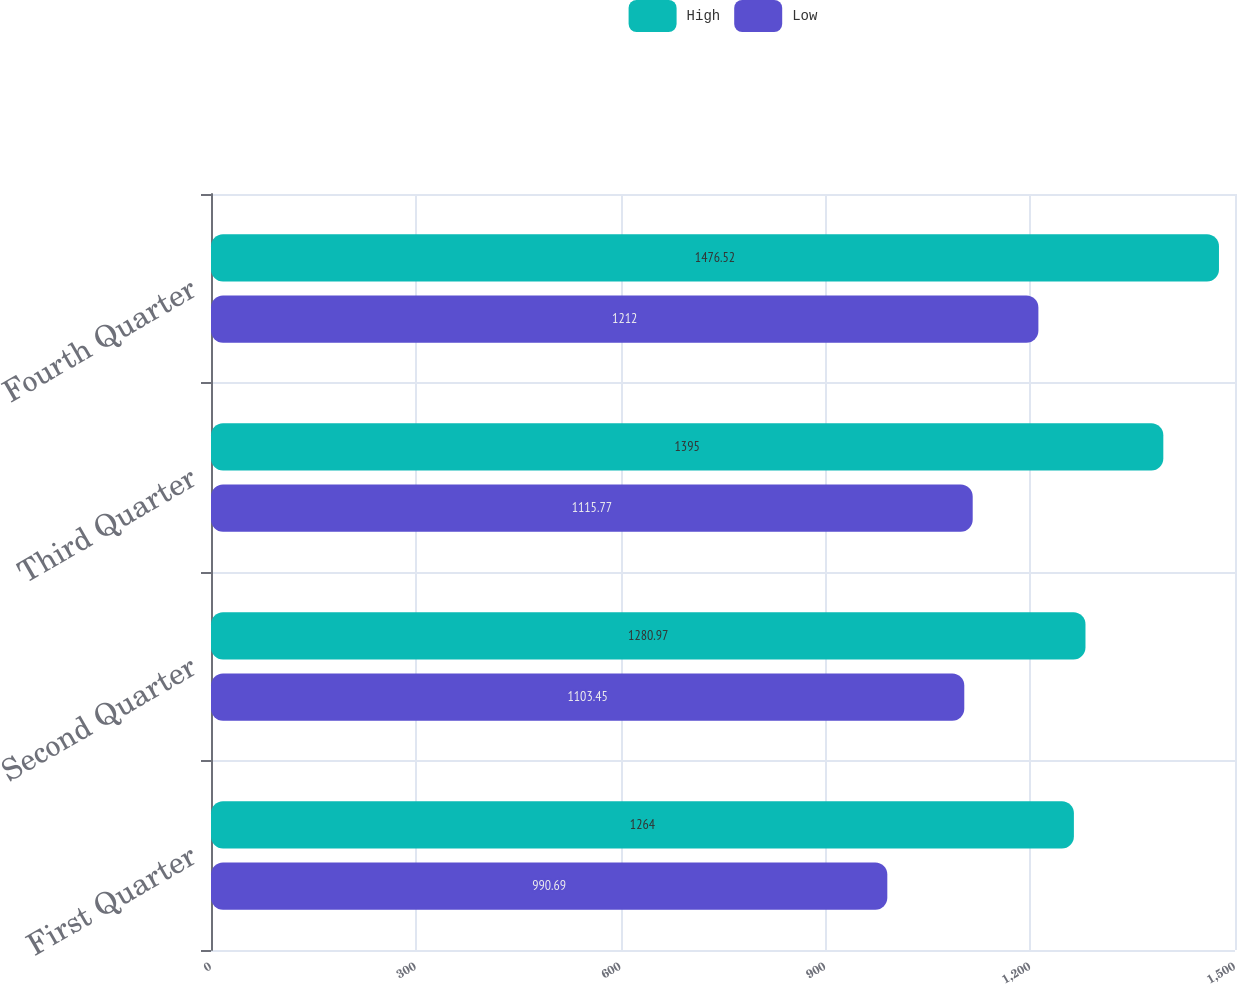<chart> <loc_0><loc_0><loc_500><loc_500><stacked_bar_chart><ecel><fcel>First Quarter<fcel>Second Quarter<fcel>Third Quarter<fcel>Fourth Quarter<nl><fcel>High<fcel>1264<fcel>1280.97<fcel>1395<fcel>1476.52<nl><fcel>Low<fcel>990.69<fcel>1103.45<fcel>1115.77<fcel>1212<nl></chart> 